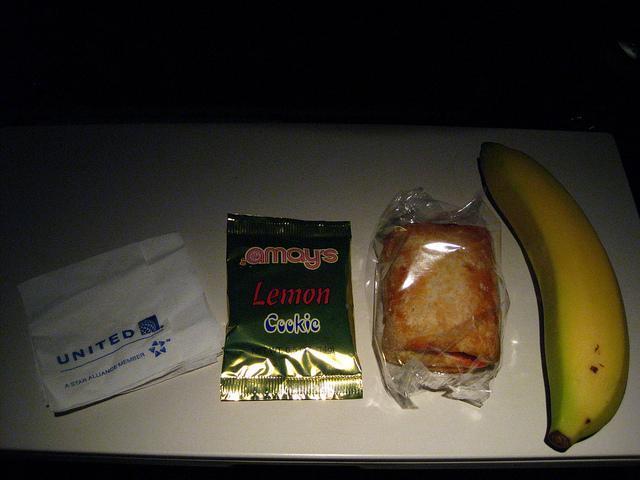How many bananas can be seen?
Give a very brief answer. 1. How many beds are in the room?
Give a very brief answer. 0. 